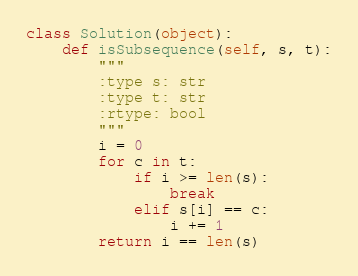Convert code to text. <code><loc_0><loc_0><loc_500><loc_500><_Python_>class Solution(object):
    def isSubsequence(self, s, t):
        """
        :type s: str
        :type t: str
        :rtype: bool
        """
        i = 0
        for c in t:
            if i >= len(s):
                break
            elif s[i] == c:
                i += 1
        return i == len(s)
</code> 